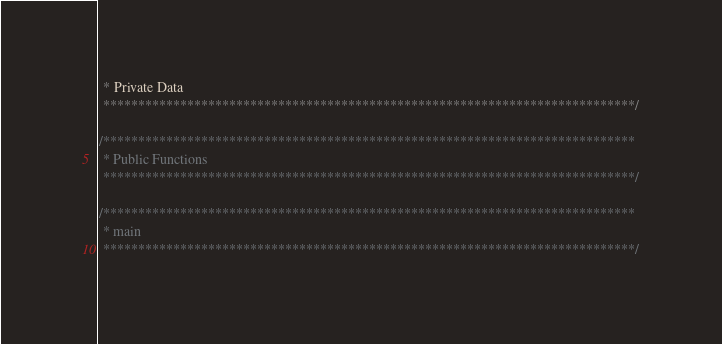<code> <loc_0><loc_0><loc_500><loc_500><_C_> * Private Data
 ****************************************************************************/

/****************************************************************************
 * Public Functions
 ****************************************************************************/

/****************************************************************************
 * main
 ****************************************************************************/
</code> 